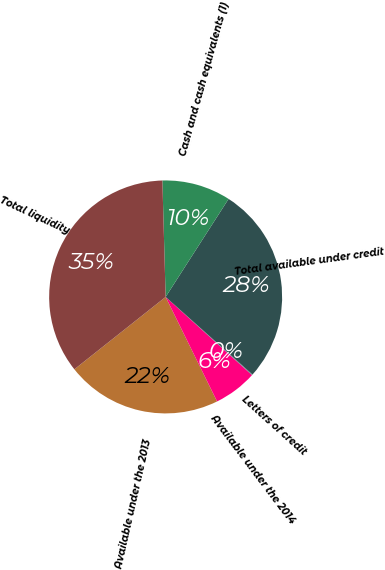Convert chart. <chart><loc_0><loc_0><loc_500><loc_500><pie_chart><fcel>Available under the 2013<fcel>Available under the 2014<fcel>Letters of credit<fcel>Total available under credit<fcel>Cash and cash equivalents (1)<fcel>Total liquidity<nl><fcel>21.61%<fcel>6.01%<fcel>0.1%<fcel>27.52%<fcel>9.53%<fcel>35.22%<nl></chart> 